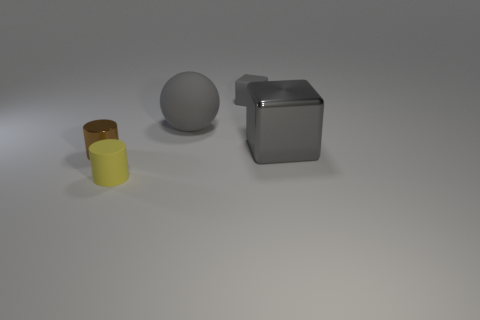Is there anything else that is made of the same material as the big gray ball?
Your response must be concise. Yes. What number of things are rubber things on the right side of the small yellow rubber thing or brown cubes?
Give a very brief answer. 2. What material is the large sphere that is the same color as the matte cube?
Provide a succinct answer. Rubber. Is there a gray metal block behind the cylinder that is behind the tiny rubber thing in front of the tiny rubber block?
Ensure brevity in your answer.  Yes. Is the number of metal cylinders that are on the right side of the gray metal cube less than the number of large metallic objects on the right side of the gray matte block?
Your response must be concise. Yes. What color is the cylinder that is made of the same material as the large gray sphere?
Your answer should be very brief. Yellow. There is a cube that is in front of the small gray block that is behind the brown cylinder; what color is it?
Offer a very short reply. Gray. Is there a thing of the same color as the matte cylinder?
Provide a succinct answer. No. What is the shape of the gray thing that is the same size as the brown object?
Your answer should be very brief. Cube. How many big gray objects are in front of the small cylinder in front of the brown metal cylinder?
Your answer should be very brief. 0. 